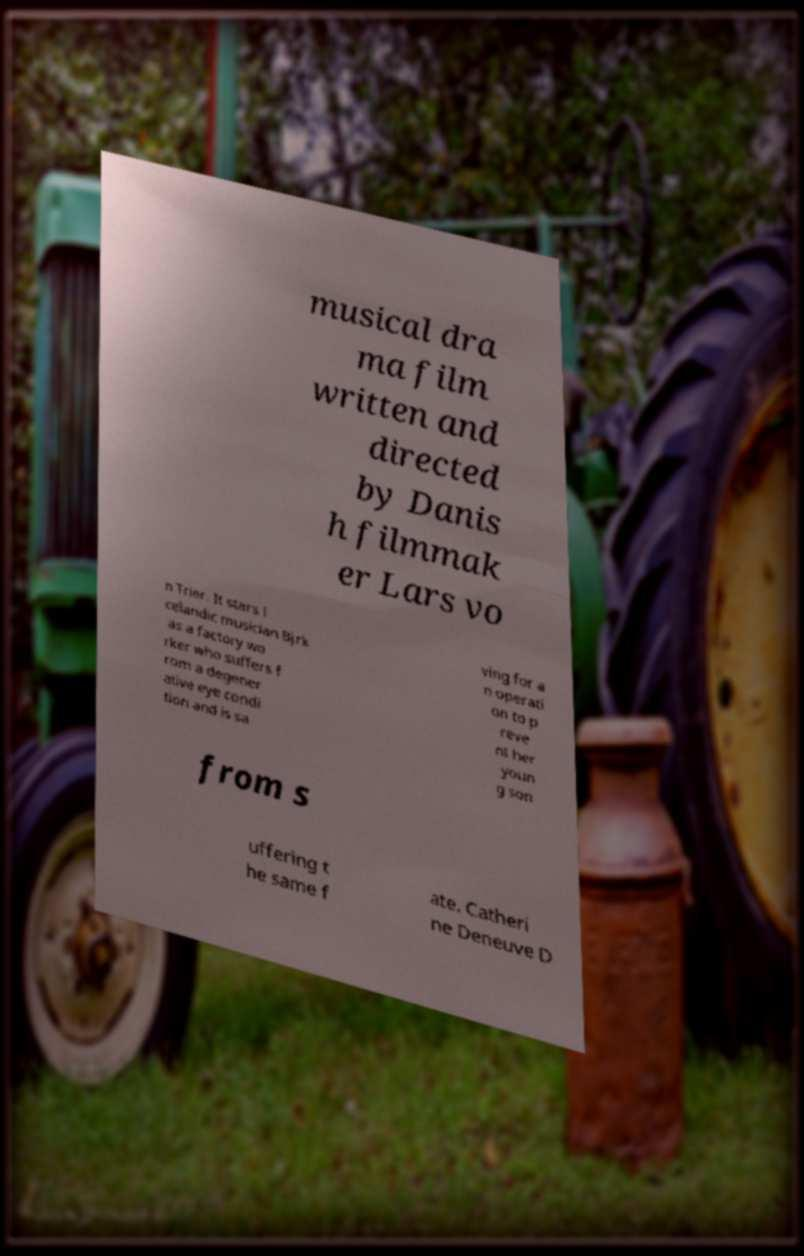For documentation purposes, I need the text within this image transcribed. Could you provide that? musical dra ma film written and directed by Danis h filmmak er Lars vo n Trier. It stars I celandic musician Bjrk as a factory wo rker who suffers f rom a degener ative eye condi tion and is sa ving for a n operati on to p reve nt her youn g son from s uffering t he same f ate. Catheri ne Deneuve D 